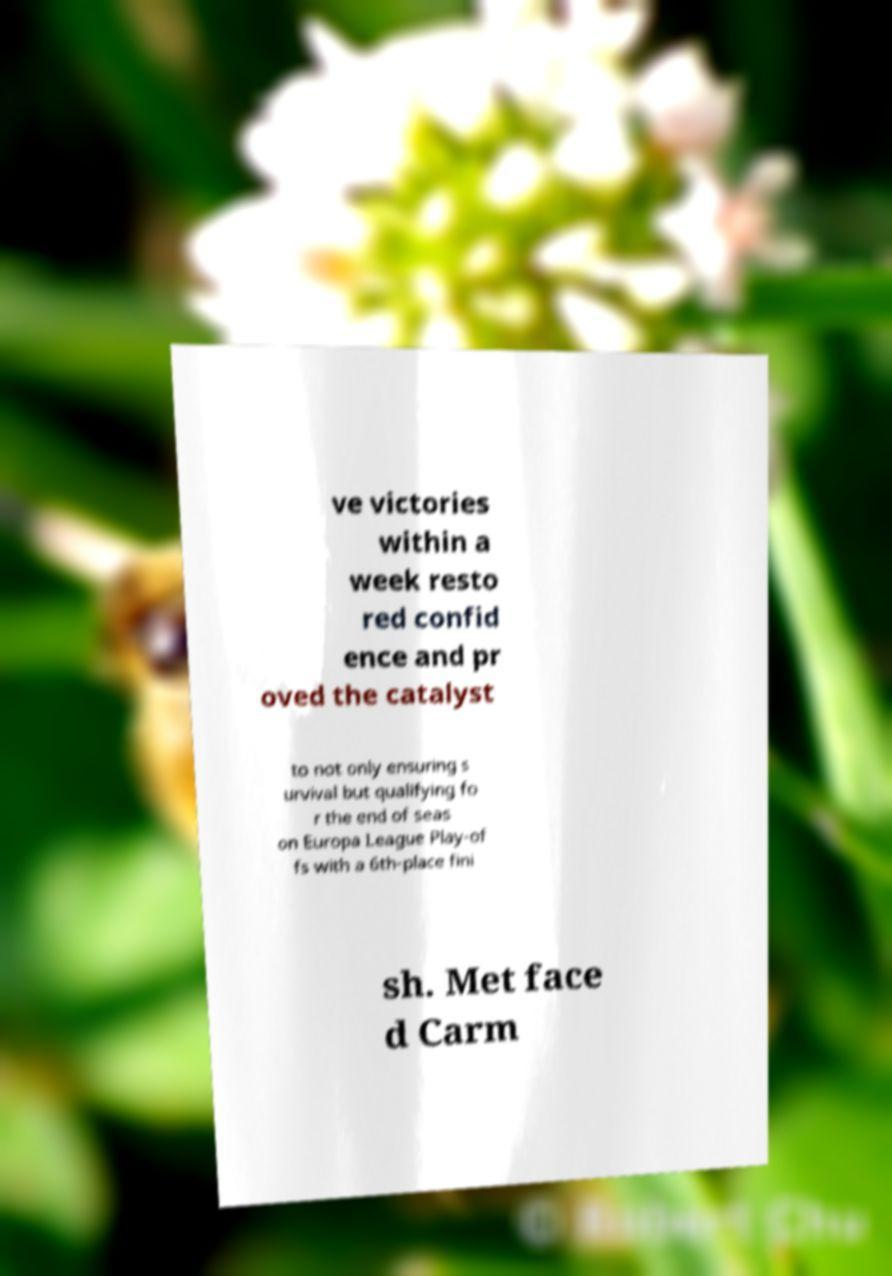For documentation purposes, I need the text within this image transcribed. Could you provide that? ve victories within a week resto red confid ence and pr oved the catalyst to not only ensuring s urvival but qualifying fo r the end of seas on Europa League Play-of fs with a 6th-place fini sh. Met face d Carm 